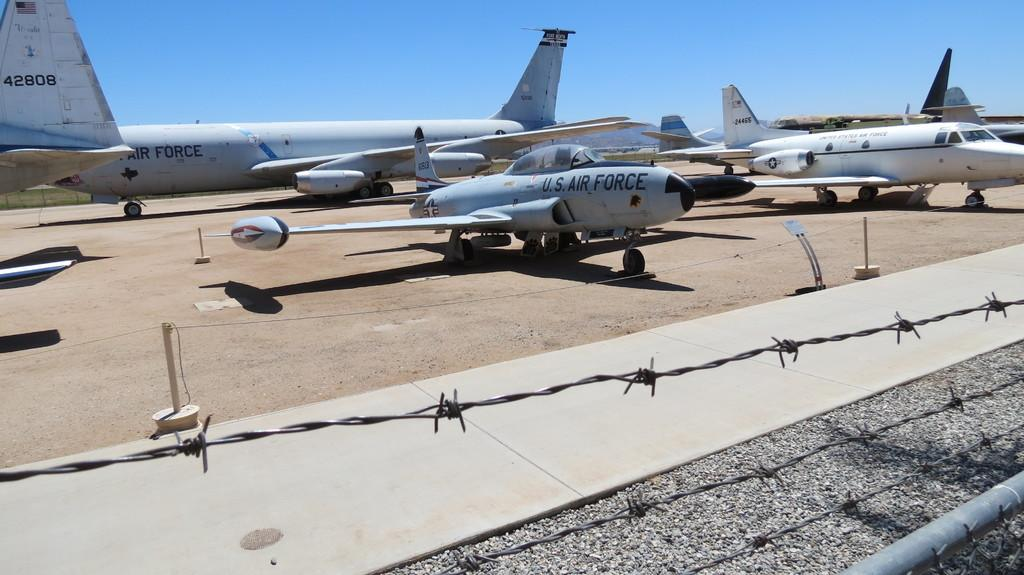<image>
Summarize the visual content of the image. Several US AIr Force planes are parked behind barbed wire. 